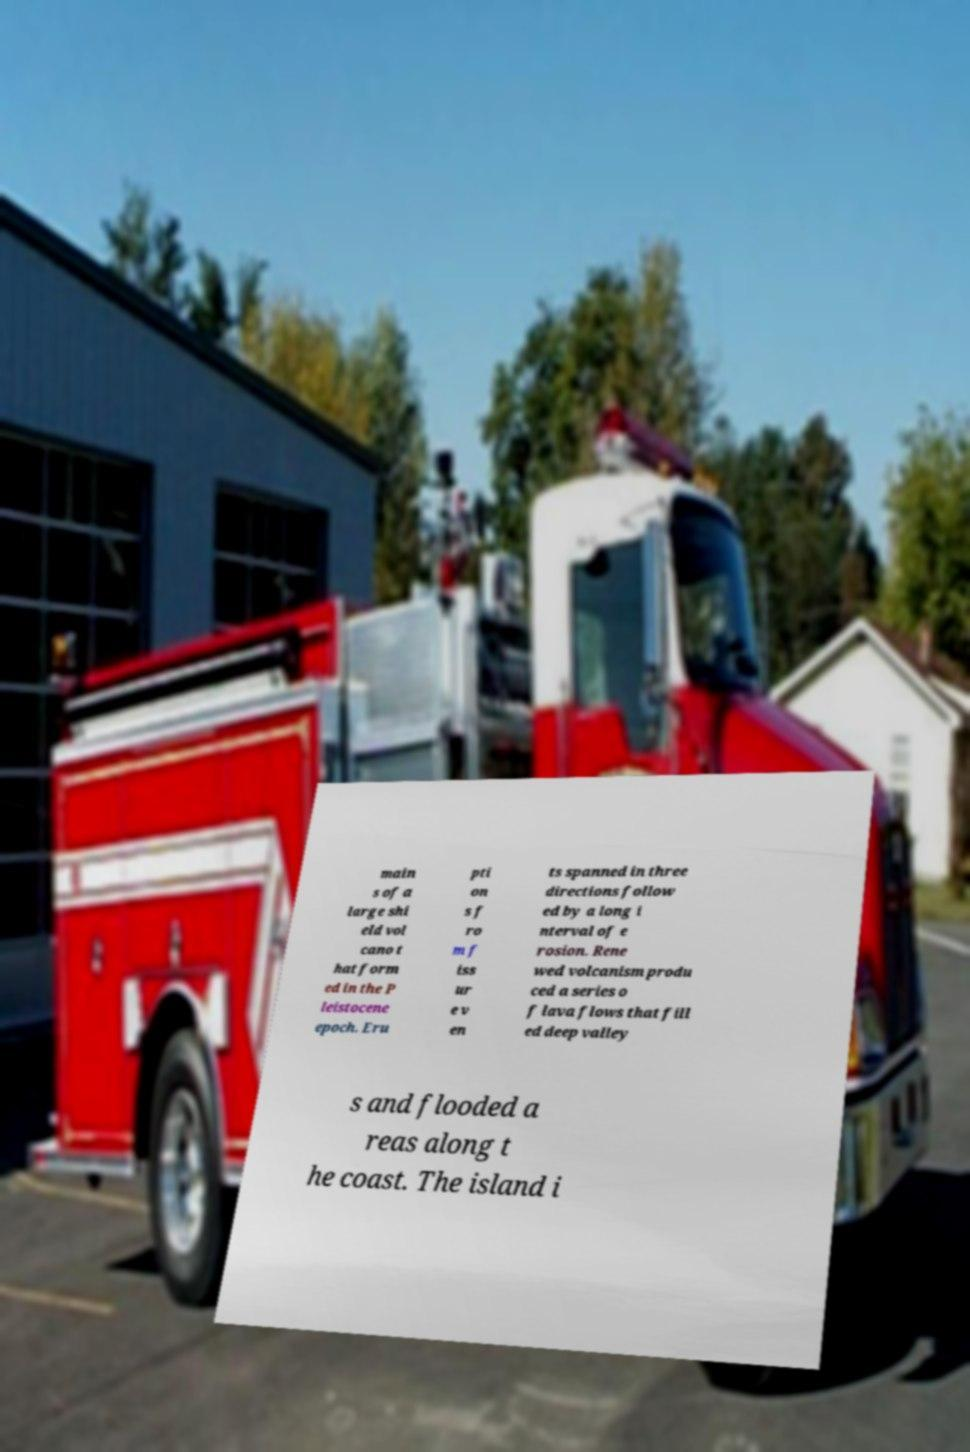What messages or text are displayed in this image? I need them in a readable, typed format. main s of a large shi eld vol cano t hat form ed in the P leistocene epoch. Eru pti on s f ro m f iss ur e v en ts spanned in three directions follow ed by a long i nterval of e rosion. Rene wed volcanism produ ced a series o f lava flows that fill ed deep valley s and flooded a reas along t he coast. The island i 